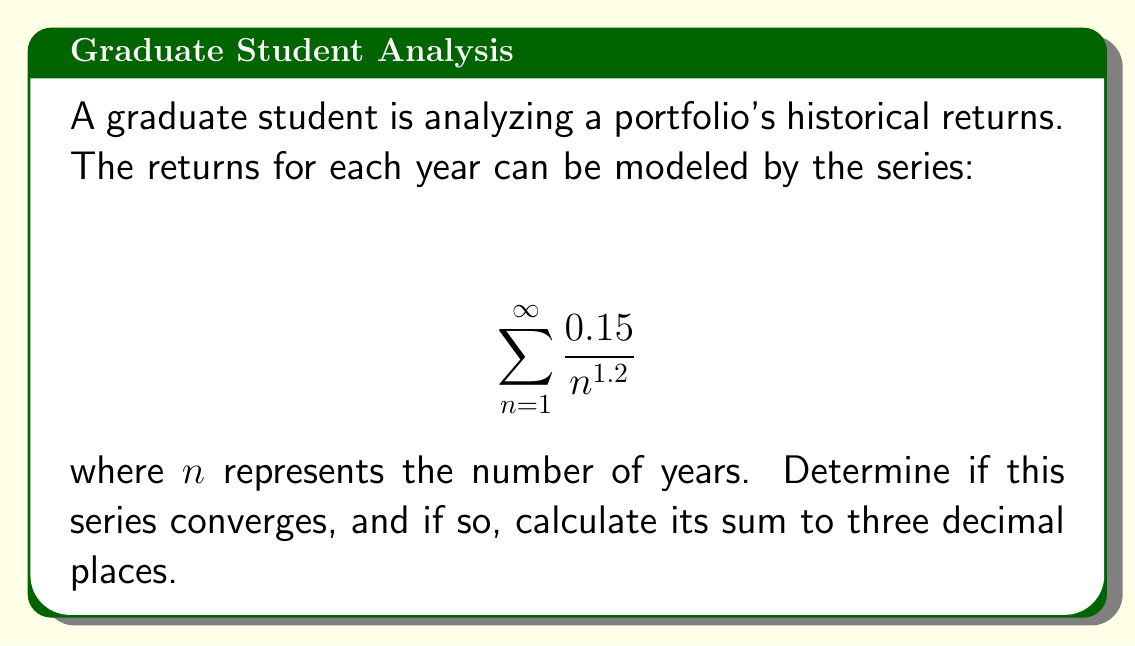Can you solve this math problem? To determine if this series converges and calculate its sum, we can follow these steps:

1. Recognize the series:
   This is a p-series of the form $\sum_{n=1}^{\infty} \frac{1}{n^p}$ where $p = 1.2$ and there's a constant factor of 0.15.

2. Convergence test:
   For a p-series, if $p > 1$, the series converges. In this case, $p = 1.2 > 1$, so the series converges.

3. Calculate the sum:
   For p-series where $p > 1$, we can use the Riemann zeta function $\zeta(p)$ to find the sum:

   $$ \sum_{n=1}^{\infty} \frac{1}{n^p} = \zeta(p) $$

   In our case:

   $$ \sum_{n=1}^{\infty} \frac{0.15}{n^{1.2}} = 0.15 \cdot \zeta(1.2) $$

4. Use a calculator or computer to evaluate $\zeta(1.2)$:
   $\zeta(1.2) \approx 5.591717...

5. Multiply by 0.15:
   $0.15 \cdot 5.591717... \approx 0.838758...$

6. Round to three decimal places:
   0.839

Therefore, the series converges to approximately 0.839.
Answer: The series converges, and its sum is approximately 0.839. 